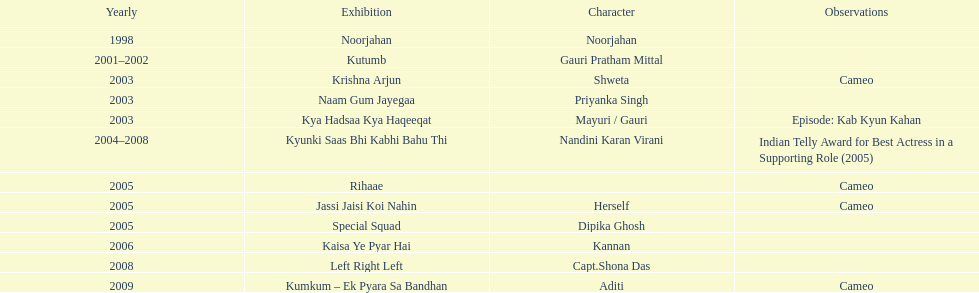How many shows were there in 2005? 3. 